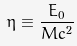Convert formula to latex. <formula><loc_0><loc_0><loc_500><loc_500>\eta \equiv \frac { E _ { 0 } } { M c ^ { 2 } }</formula> 